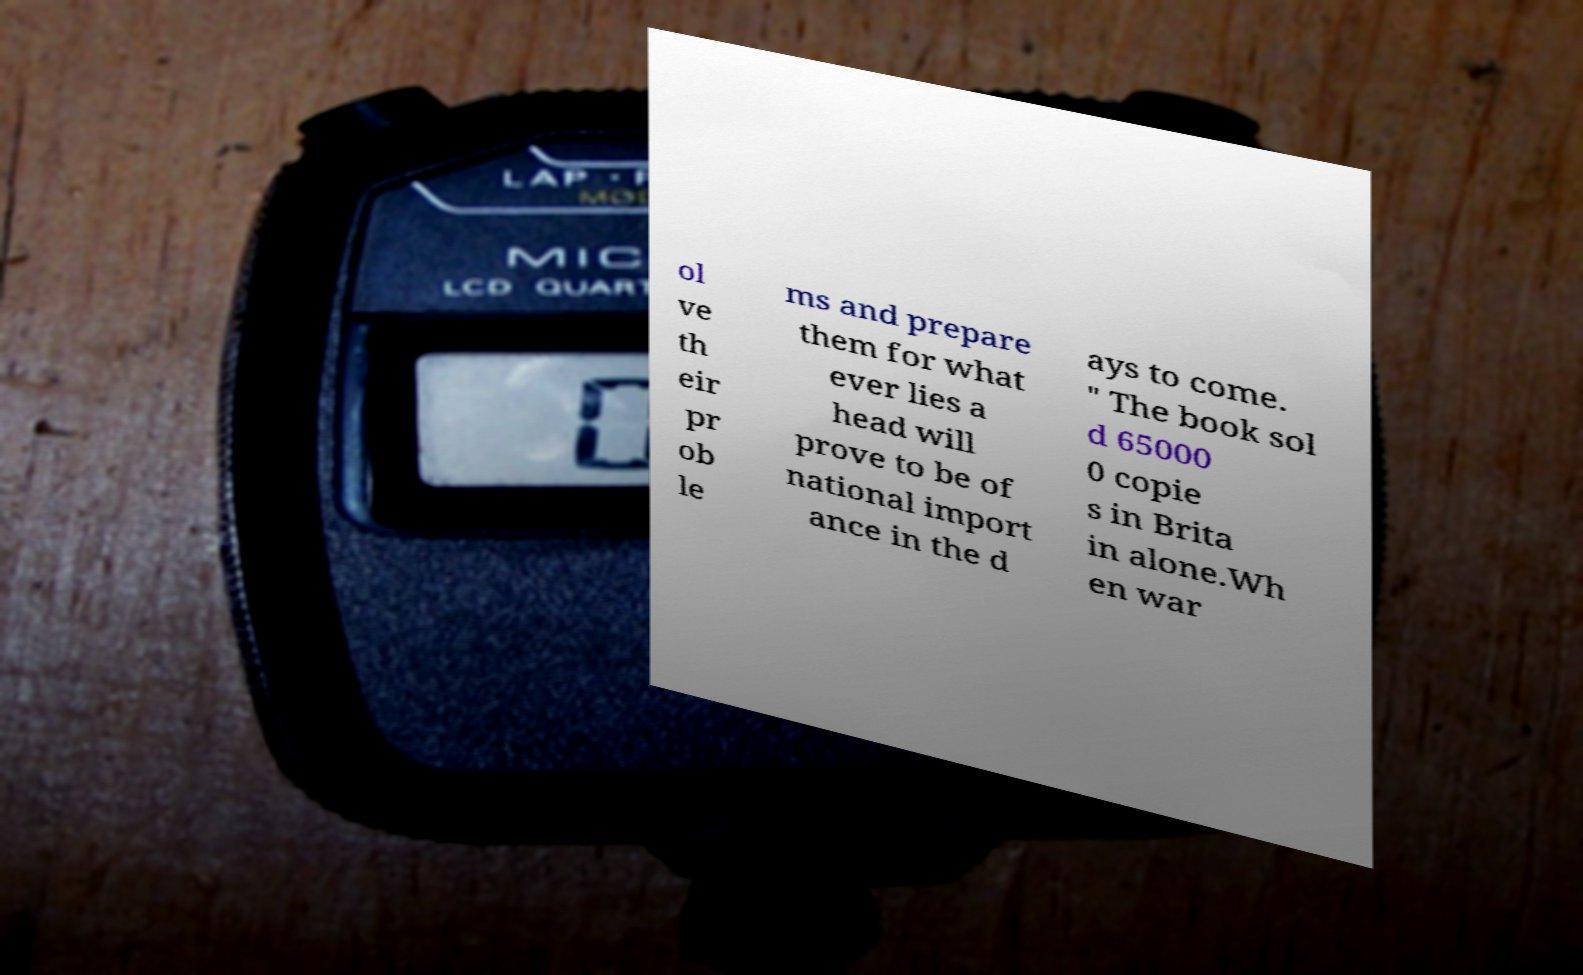What messages or text are displayed in this image? I need them in a readable, typed format. ol ve th eir pr ob le ms and prepare them for what ever lies a head will prove to be of national import ance in the d ays to come. " The book sol d 65000 0 copie s in Brita in alone.Wh en war 